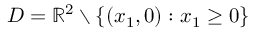Convert formula to latex. <formula><loc_0><loc_0><loc_500><loc_500>D = \mathbb { R } ^ { 2 } \ \left \{ ( x _ { 1 } , 0 ) \colon x _ { 1 } \geq 0 \right \}</formula> 